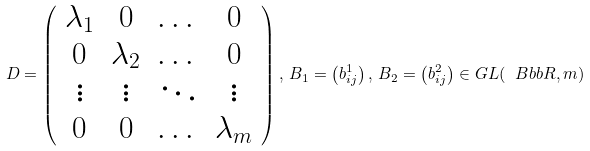Convert formula to latex. <formula><loc_0><loc_0><loc_500><loc_500>D = \left ( \begin{array} { c c c c } \lambda _ { 1 } & 0 & \dots & 0 \\ 0 & \lambda _ { 2 } & \dots & 0 \\ \vdots & \vdots & \ddots & \vdots \\ 0 & 0 & \dots & \lambda _ { m } \end{array} \right ) , \, B _ { 1 } = \left ( b _ { i j } ^ { 1 } \right ) , \, B _ { 2 } = \left ( b _ { i j } ^ { 2 } \right ) \in G L ( { \ B b b R } , m )</formula> 